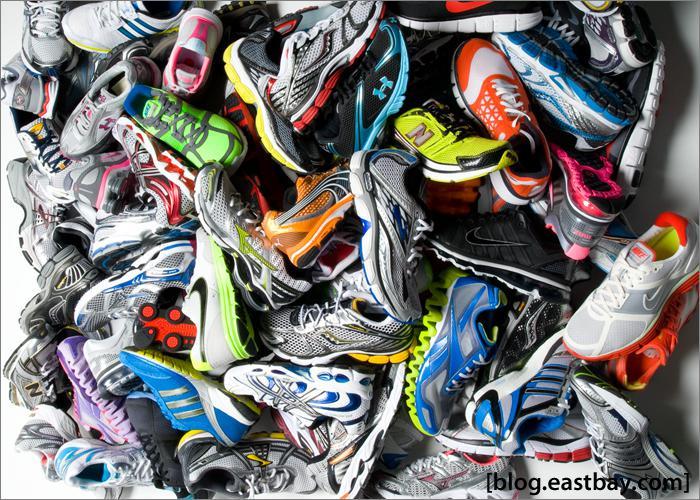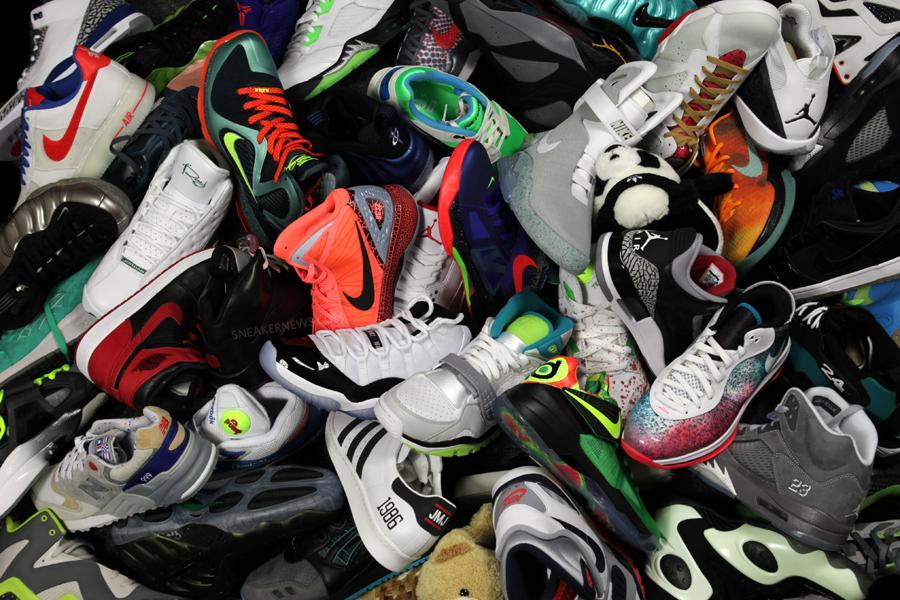The first image is the image on the left, the second image is the image on the right. Analyze the images presented: Is the assertion "An image shows shoes lined up in rows in store displays." valid? Answer yes or no. No. 